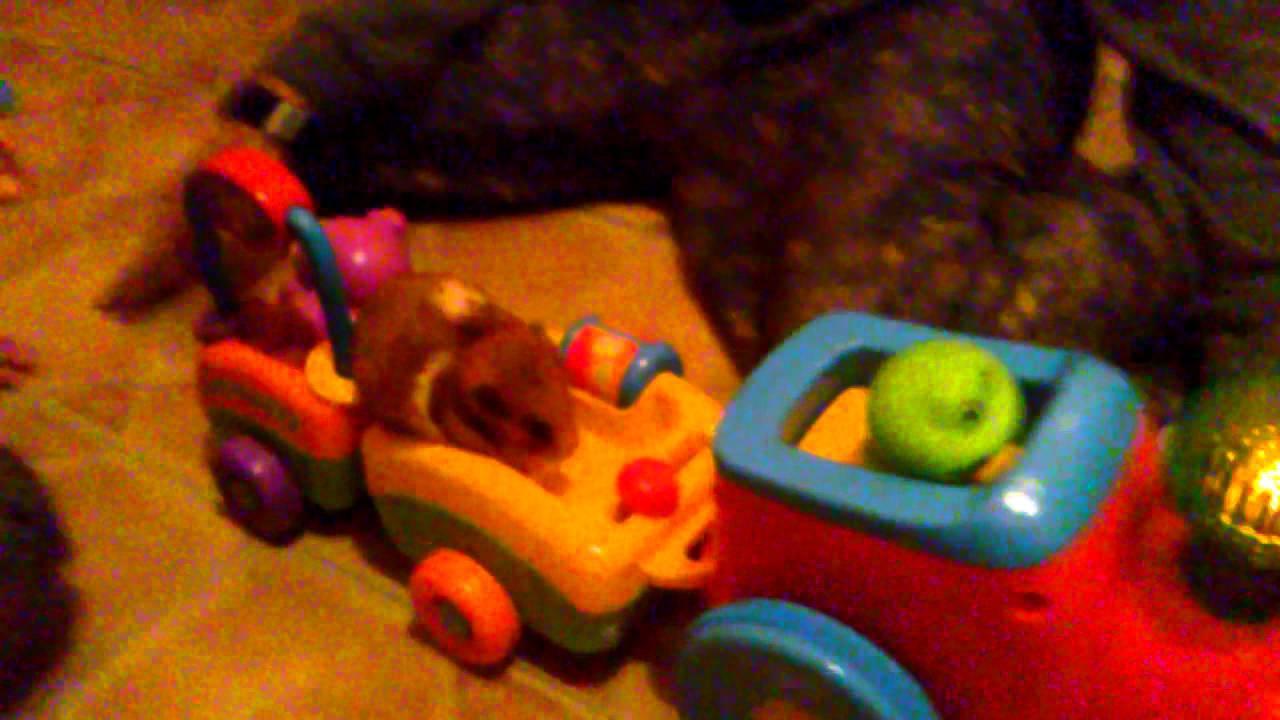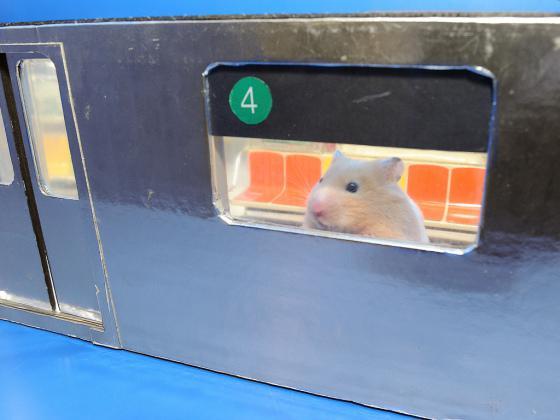The first image is the image on the left, the second image is the image on the right. Analyze the images presented: Is the assertion "There are two mice near yellow and orange seats." valid? Answer yes or no. No. 